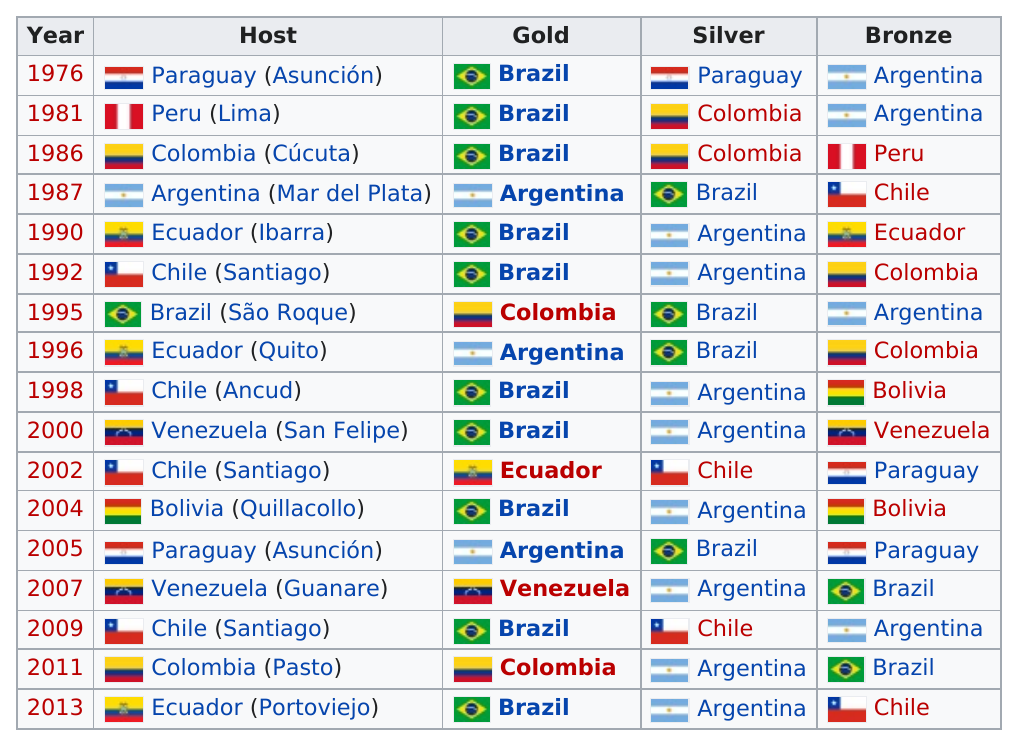Point out several critical features in this image. The host country has won the silver medal 5 times, and the country that won silver is the same as the host country. According to the provided information, Brazil and Argentina have not won gold on four occasions. Argentina has the highest number of bronze wins among all countries. Paraguay hosted the tournament prior to 1981 in Asunción. During the years of 1987, 2002, 2009, and 2013, Chile placed either silver or bronze in the Summer Olympic Games. 